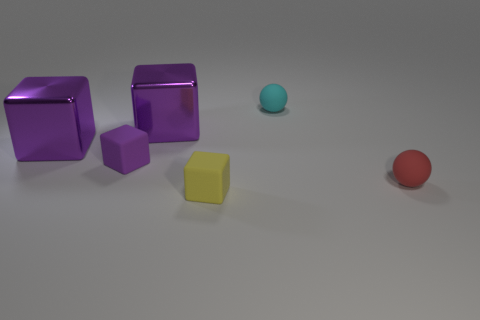Subtract all tiny yellow matte cubes. How many cubes are left? 3 Subtract all red balls. How many balls are left? 1 Subtract all spheres. How many objects are left? 4 Add 1 big blue shiny objects. How many objects exist? 7 Subtract 2 cubes. How many cubes are left? 2 Subtract all gray spheres. How many cyan cubes are left? 0 Subtract all rubber spheres. Subtract all small rubber things. How many objects are left? 0 Add 3 purple metal things. How many purple metal things are left? 5 Add 3 purple metal balls. How many purple metal balls exist? 3 Subtract 1 red balls. How many objects are left? 5 